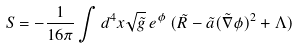Convert formula to latex. <formula><loc_0><loc_0><loc_500><loc_500>S = - \frac { 1 } { 1 6 \pi } \int d ^ { 4 } x \sqrt { \tilde { g } } \, e ^ { \phi } \, ( \tilde { R } - \tilde { a } ( \tilde { \nabla } \phi ) ^ { 2 } + \Lambda )</formula> 